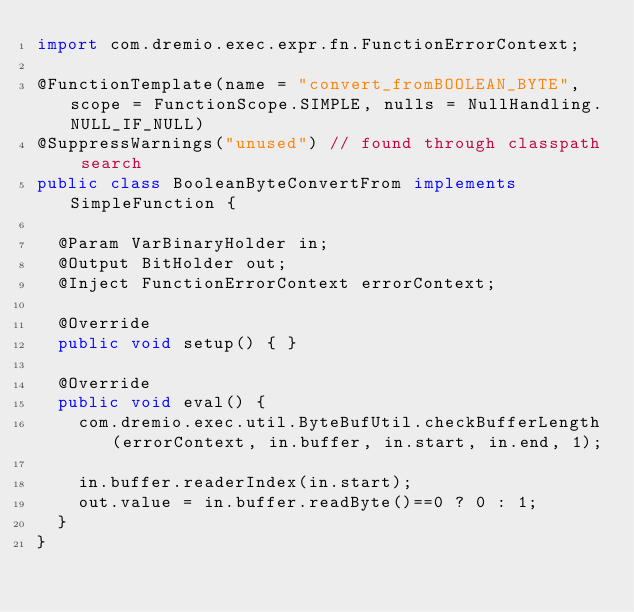Convert code to text. <code><loc_0><loc_0><loc_500><loc_500><_Java_>import com.dremio.exec.expr.fn.FunctionErrorContext;

@FunctionTemplate(name = "convert_fromBOOLEAN_BYTE", scope = FunctionScope.SIMPLE, nulls = NullHandling.NULL_IF_NULL)
@SuppressWarnings("unused") // found through classpath search
public class BooleanByteConvertFrom implements SimpleFunction {

  @Param VarBinaryHolder in;
  @Output BitHolder out;
  @Inject FunctionErrorContext errorContext;

  @Override
  public void setup() { }

  @Override
  public void eval() {
    com.dremio.exec.util.ByteBufUtil.checkBufferLength(errorContext, in.buffer, in.start, in.end, 1);

    in.buffer.readerIndex(in.start);
    out.value = in.buffer.readByte()==0 ? 0 : 1;
  }
}
</code> 